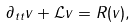Convert formula to latex. <formula><loc_0><loc_0><loc_500><loc_500>\partial _ { t t } v + \mathcal { L } v = R ( v ) ,</formula> 